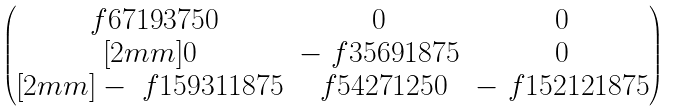<formula> <loc_0><loc_0><loc_500><loc_500>\begin{pmatrix} \ f { 6 7 1 9 } { 3 7 5 0 } & 0 & 0 \\ [ 2 m m ] 0 & - \ f { 3 5 6 9 } { 1 8 7 5 } & 0 \\ [ 2 m m ] - \ f { 1 5 9 3 1 } { 1 8 7 5 } & \ f { 5 4 2 7 } { 1 2 5 0 } & - \ f { 1 5 2 1 2 } { 1 8 7 5 } \end{pmatrix}</formula> 